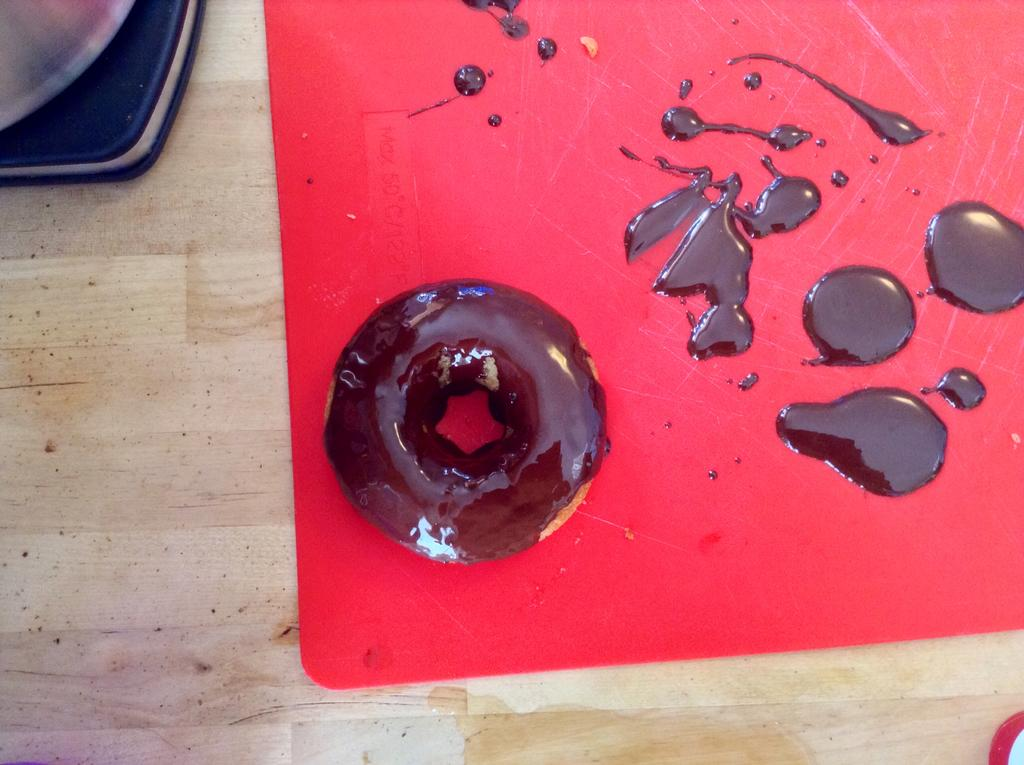What type of food is in the image? There is a doughnut in the image. How is the doughnut prepared? The doughnut is dipped in chocolate syrup. What is the color of the mat in the image? There is a red mat in the image. Can you see a boy playing with a bubble in the image? There is no boy or bubble present in the image. 